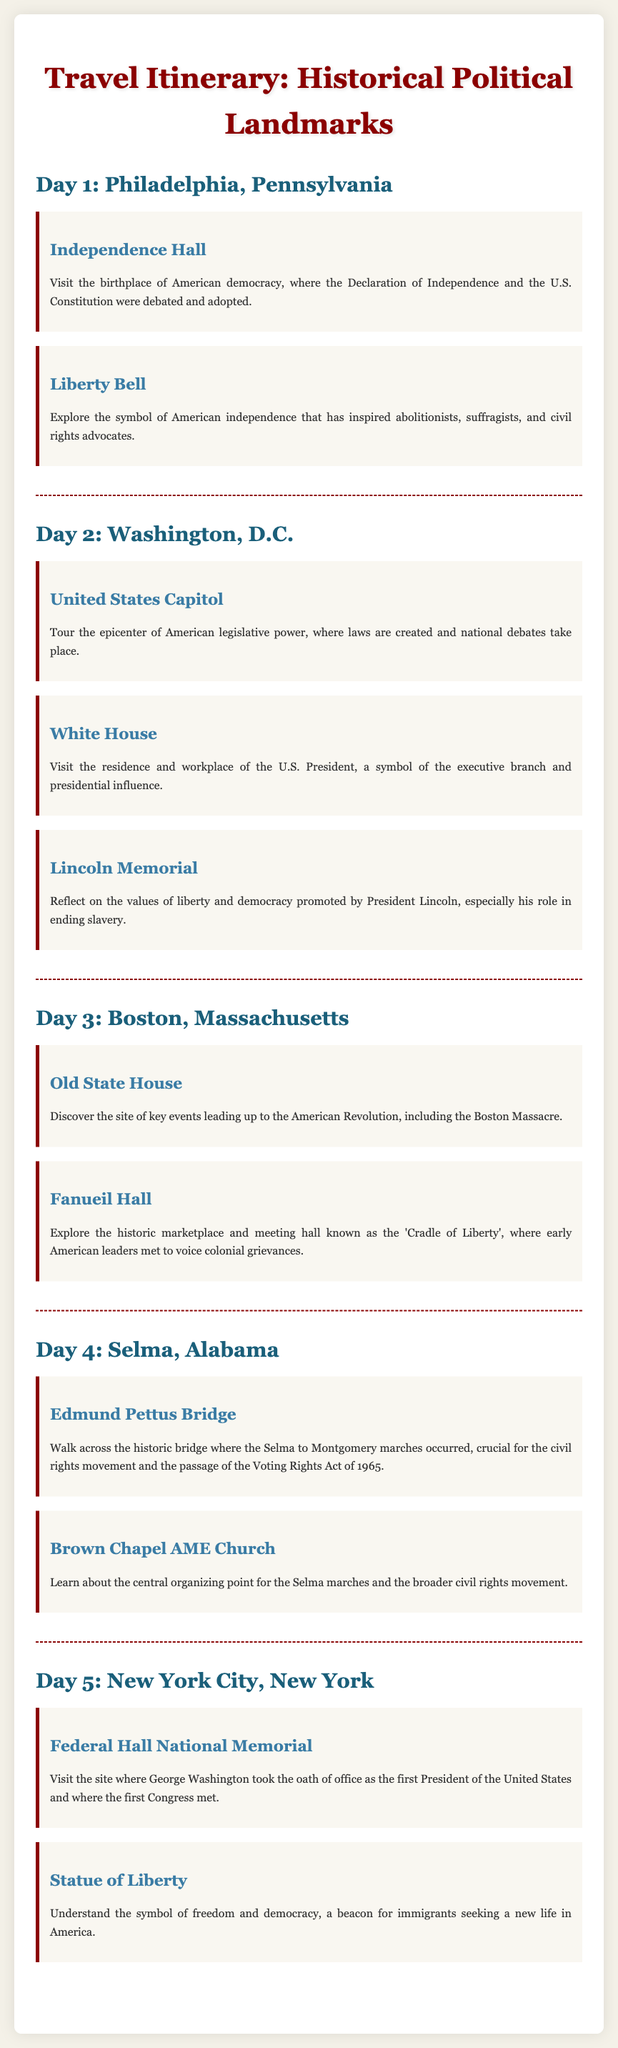What is the first landmark visited in Philadelphia? The document specifies that the first landmark visited in Philadelphia is Independence Hall.
Answer: Independence Hall What day is dedicated to Washington, D.C.? The document indicates that Day 2 is dedicated to Washington, D.C.
Answer: Day 2 What significant event took place at the Edmund Pettus Bridge? The document notes that the bridge was a crucial site for the Selma to Montgomery marches, important for the civil rights movement.
Answer: Selma to Montgomery marches How many landmarks are listed for Boston? The document mentions two landmarks listed for Boston: Old State House and Fanueil Hall.
Answer: Two Which landmark symbolizes the start of the U.S. Presidency? Federal Hall National Memorial is identified in the document as the site where George Washington took the oath of office as the first President of the United States.
Answer: Federal Hall National Memorial What type of site is Fanueil Hall referred to as? The document describes Fanueil Hall as known as the 'Cradle of Liberty'.
Answer: 'Cradle of Liberty' How many days are included in the itinerary? The document outlines a total of five days included in the itinerary.
Answer: Five What landmark is a symbol of freedom and democracy? The Statue of Liberty is highlighted in the document as a symbol of freedom and democracy.
Answer: Statue of Liberty What is the last destination mentioned in the itinerary? The itinerary ends with New York City, which is the last destination listed.
Answer: New York City 